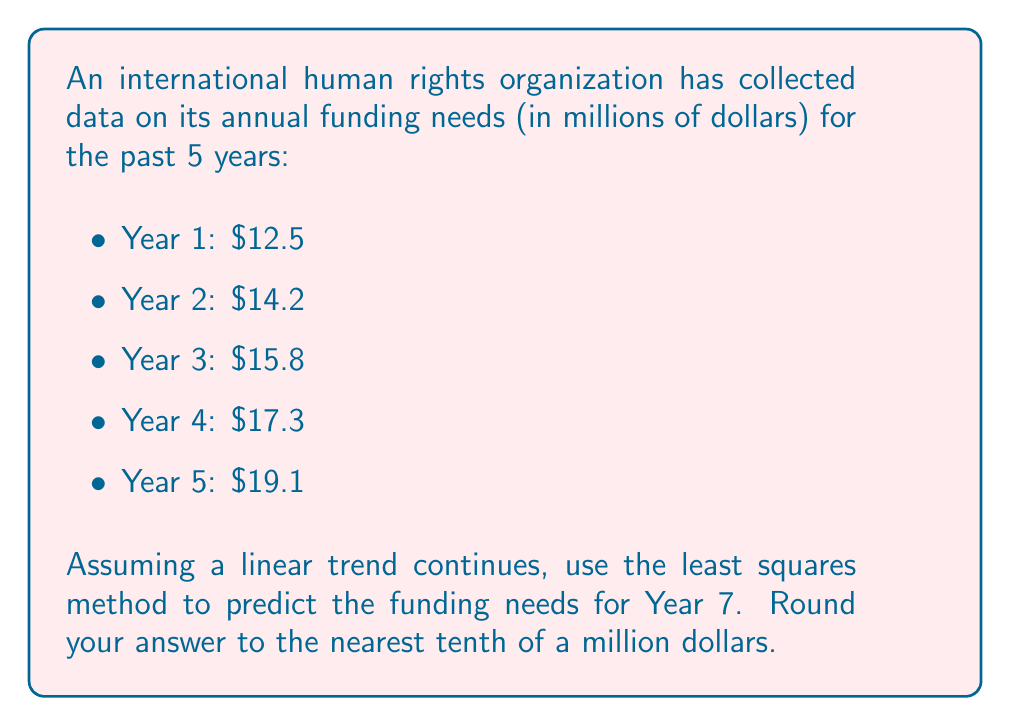Can you solve this math problem? To predict future funding needs based on historical data, we can use the least squares method for linear regression. This method fits a straight line to the data that minimizes the sum of squared residuals.

Let's follow these steps:

1) First, we need to set up our data. Let $x$ represent the year (with Year 1 as $x=1$, Year 2 as $x=2$, etc.) and $y$ represent the funding needs.

   $x$: 1, 2, 3, 4, 5
   $y$: 12.5, 14.2, 15.8, 17.3, 19.1

2) We'll use the following formulas for the slope $(m)$ and y-intercept $(b)$ of the best-fit line:

   $$m = \frac{n\sum xy - \sum x \sum y}{n\sum x^2 - (\sum x)^2}$$

   $$b = \frac{\sum y - m\sum x}{n}$$

   where $n$ is the number of data points.

3) Let's calculate the necessary sums:
   
   $n = 5$
   $\sum x = 1 + 2 + 3 + 4 + 5 = 15$
   $\sum y = 12.5 + 14.2 + 15.8 + 17.3 + 19.1 = 78.9$
   $\sum xy = (1)(12.5) + (2)(14.2) + (3)(15.8) + (4)(17.3) + (5)(19.1) = 262.3$
   $\sum x^2 = 1^2 + 2^2 + 3^2 + 4^2 + 5^2 = 55$

4) Now we can calculate $m$:

   $$m = \frac{5(262.3) - (15)(78.9)}{5(55) - (15)^2} = \frac{1311.5 - 1183.5}{275 - 225} = \frac{128}{50} = 1.64$$

5) And $b$:

   $$b = \frac{78.9 - 1.64(15)}{5} = \frac{78.9 - 24.6}{5} = 10.86$$

6) Our best-fit line equation is thus:

   $$y = 1.64x + 10.86$$

7) To predict Year 7, we substitute $x = 7$:

   $$y = 1.64(7) + 10.86 = 11.48 + 10.86 = 22.34$$

8) Rounding to the nearest tenth:

   22.3 million dollars
Answer: $22.3 million 